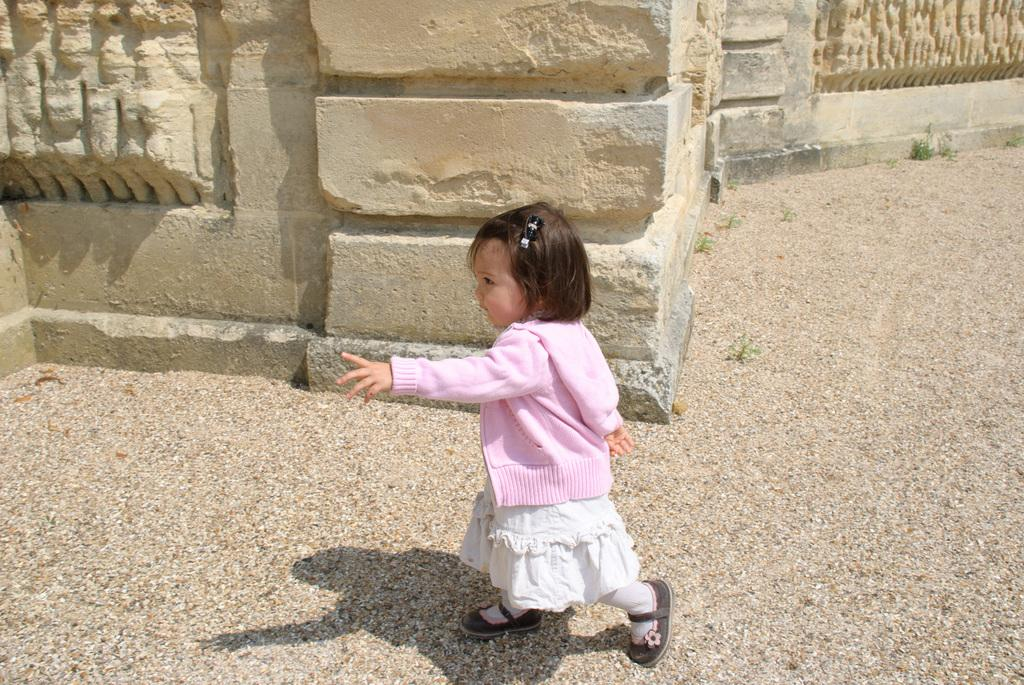What is the primary surface visible in the image? There is a floor in the image. What is the girl in the image doing? A small girl is walking in the image. What color is the jacket the girl is wearing? The girl is wearing a pink color jacket. What can be seen in the background of the image? There is a wall in the background of the image. What type of metal is the girl's elbow made of in the image? The girl's elbow is not made of metal, and there is no mention of metal in the image. 